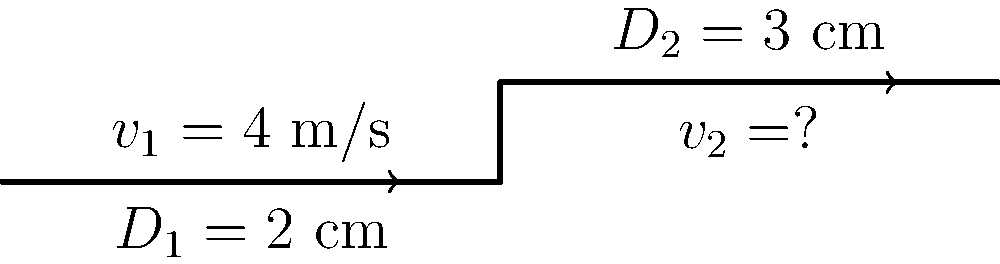A pipe has two sections with different diameters. The first section has a diameter $D_1 = 2$ cm and a flow velocity $v_1 = 4$ m/s. The second section has a diameter $D_2 = 3$ cm. Assuming the fluid is incompressible, what is the velocity $v_2$ in the second section of the pipe? To solve this problem, we'll use the continuity equation for incompressible flow:

1) The continuity equation states that the mass flow rate is constant throughout the pipe:

   $$Q_1 = Q_2$$

   where $Q$ is the volumetric flow rate.

2) The volumetric flow rate is given by the product of velocity and cross-sectional area:

   $$A_1v_1 = A_2v_2$$

3) The cross-sectional area of a circular pipe is $A = \frac{\pi D^2}{4}$, so we can write:

   $$\frac{\pi D_1^2}{4}v_1 = \frac{\pi D_2^2}{4}v_2$$

4) The $\frac{\pi}{4}$ terms cancel out, giving us:

   $$D_1^2v_1 = D_2^2v_2$$

5) Now we can substitute the known values:

   $$(2\text{ cm})^2 \cdot 4\text{ m/s} = (3\text{ cm})^2 \cdot v_2$$

6) Simplify:

   $$16\text{ cm}^2\text{ m/s} = 9\text{ cm}^2 \cdot v_2$$

7) Solve for $v_2$:

   $$v_2 = \frac{16\text{ cm}^2\text{ m/s}}{9\text{ cm}^2} = \frac{16}{9}\text{ m/s}$$

Therefore, the velocity in the second section of the pipe is $\frac{16}{9}$ m/s or approximately 1.78 m/s.
Answer: $\frac{16}{9}$ m/s 